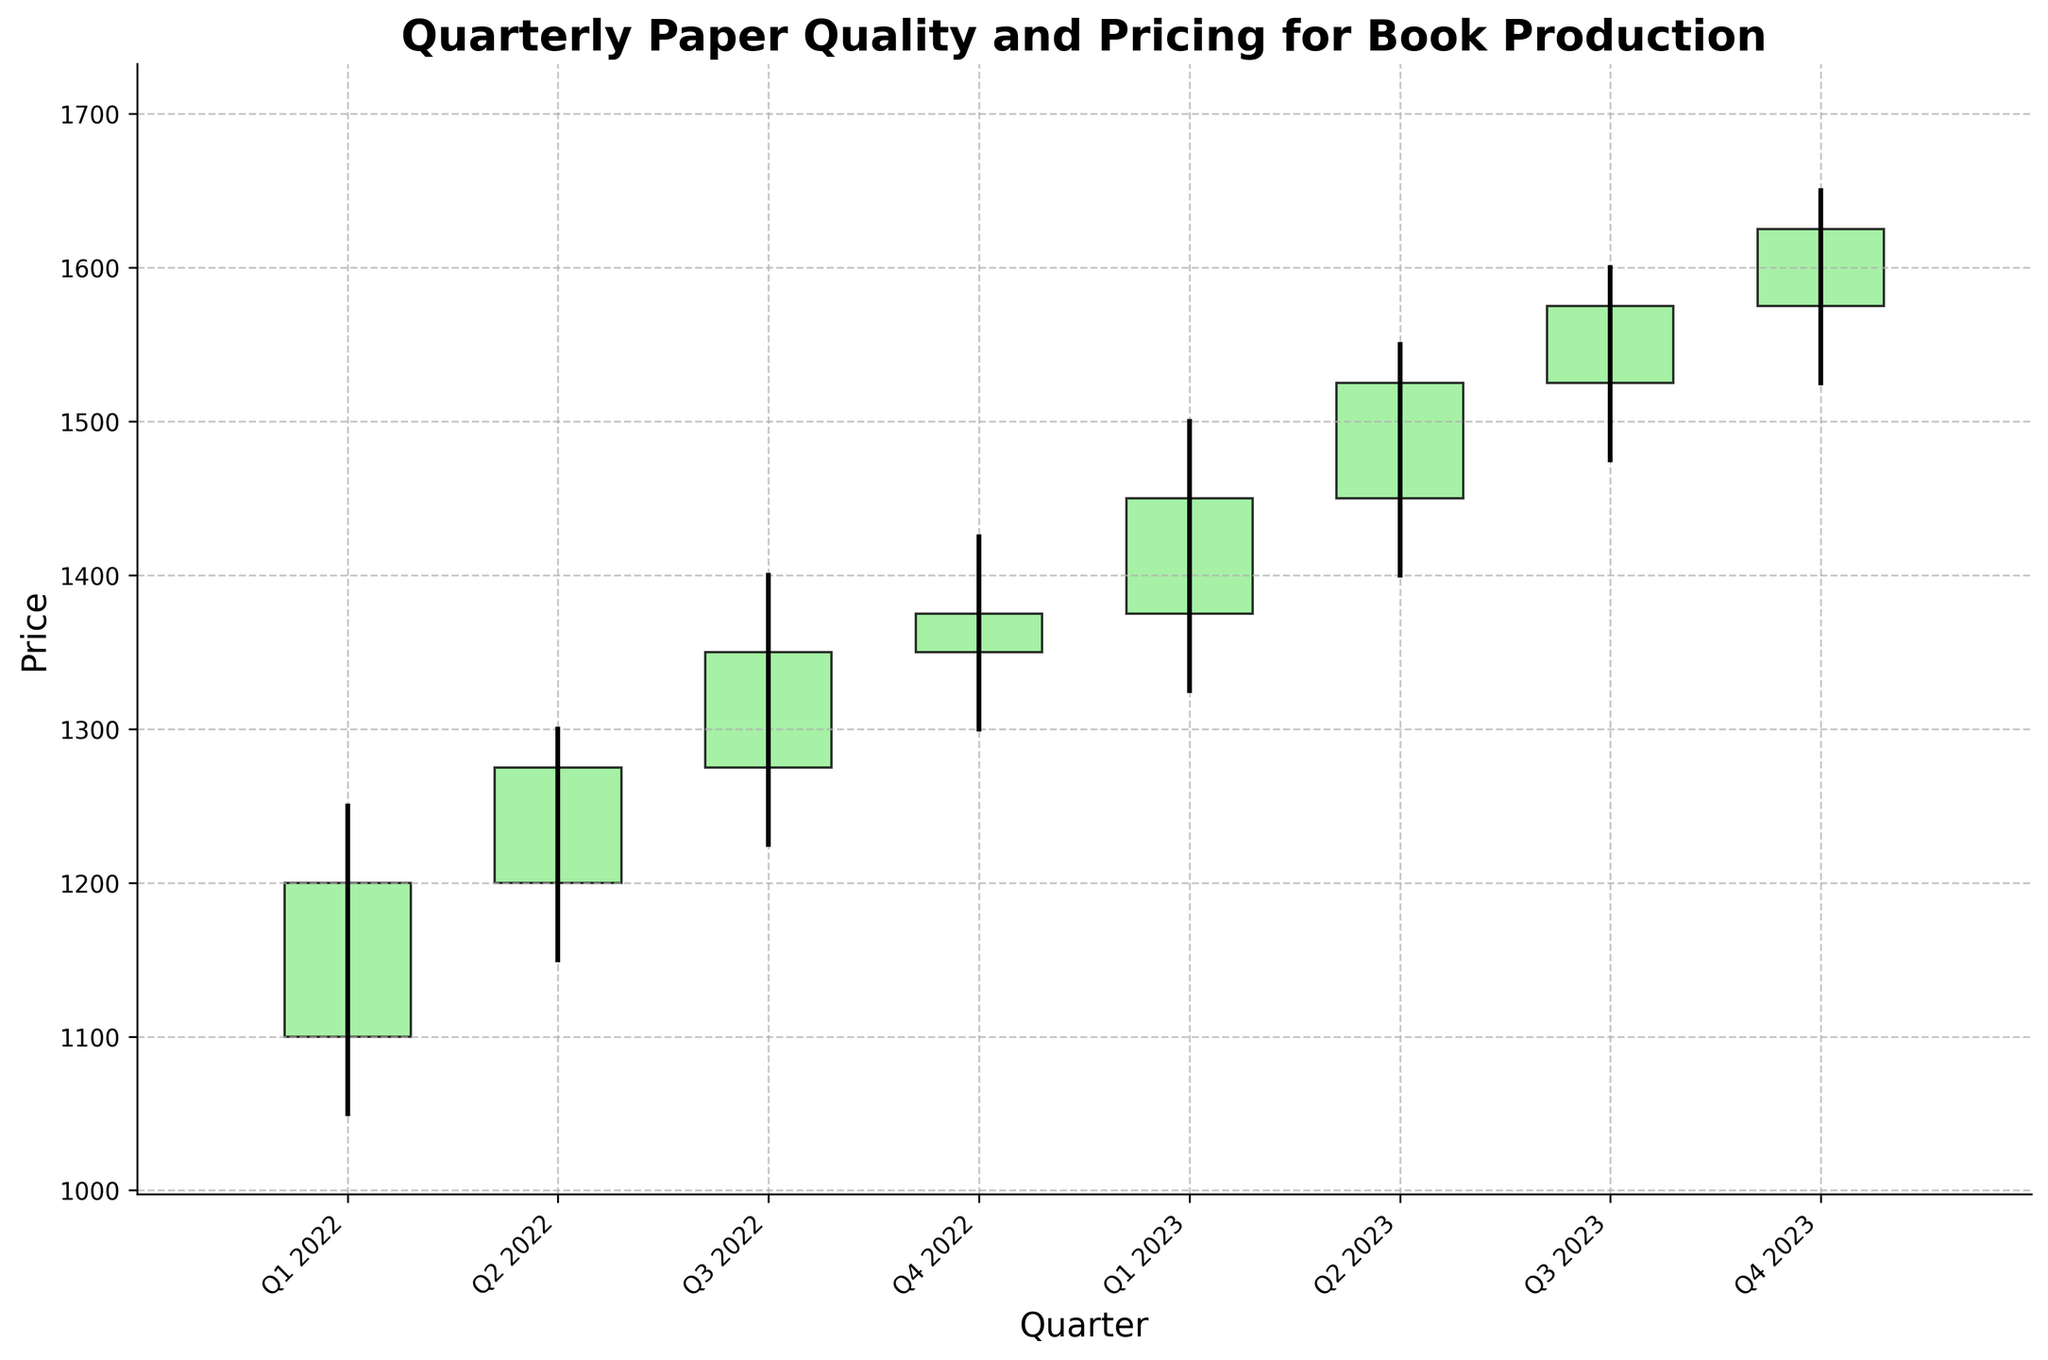What is the title of the chart? The title of the chart is displayed at the top and reads 'Quarterly Paper Quality and Pricing for Book Production'.
Answer: Quarterly Paper Quality and Pricing for Book Production How many quarters are displayed in the chart? There are eight labeled data points along the x-axis, representing the four quarters of each year from Q1 2022 to Q4 2023.
Answer: Eight quarters Which quarter had the highest closing price? By observing the closing prices for each quarter, the highest closing price is seen in Q4 2023, where it closes at 1625.
Answer: Q4 2023 What is the lowest price reached during Q1 2022? The lowest price for Q1 2022 is observed on the chart as 1050.
Answer: 1050 What is the overall trend from Q1 2022 to Q4 2023 in terms of closing prices? Observing the entire chart, the closing prices show a consistent upward trend from Q1 2022 to Q4 2023.
Answer: Upward trend Which quarter shows the greatest difference between its high and low prices? The greatest difference is found by calculating the high minus the low for each quarter. Q1 2023 has the highest range with a high of 1500 and a low of 1325, resulting in a difference of 175.
Answer: Q1 2023 What is the average closing price for the year 2022? Summing up the closing prices for each quarter in 2022 (1200, 1275, 1350, 1375) and then dividing by the number of quarters (4), the average is (1200+1275+1350+1375)/4 = 1300.
Answer: 1300 How does the closing price change from Q2 2023 to Q3 2023? By observing Q2 2023's closing price of 1525 and Q3 2023's closing price of 1575, there is an increase of 50 points.
Answer: Increases by 50 In which quarter did the closing price exceed the opening price the most? The difference between closing and opening prices is highest in Q1 2023, with opening at 1375 and closing at 1450, showing a 75-point increase.
Answer: Q1 2023 How did the closing price change from Q4 2022 to Q1 2023? From Q4 2022’s closing price of 1375 to Q1 2023’s closing price of 1450, the closing price increased by 75 points.
Answer: Increased by 75 